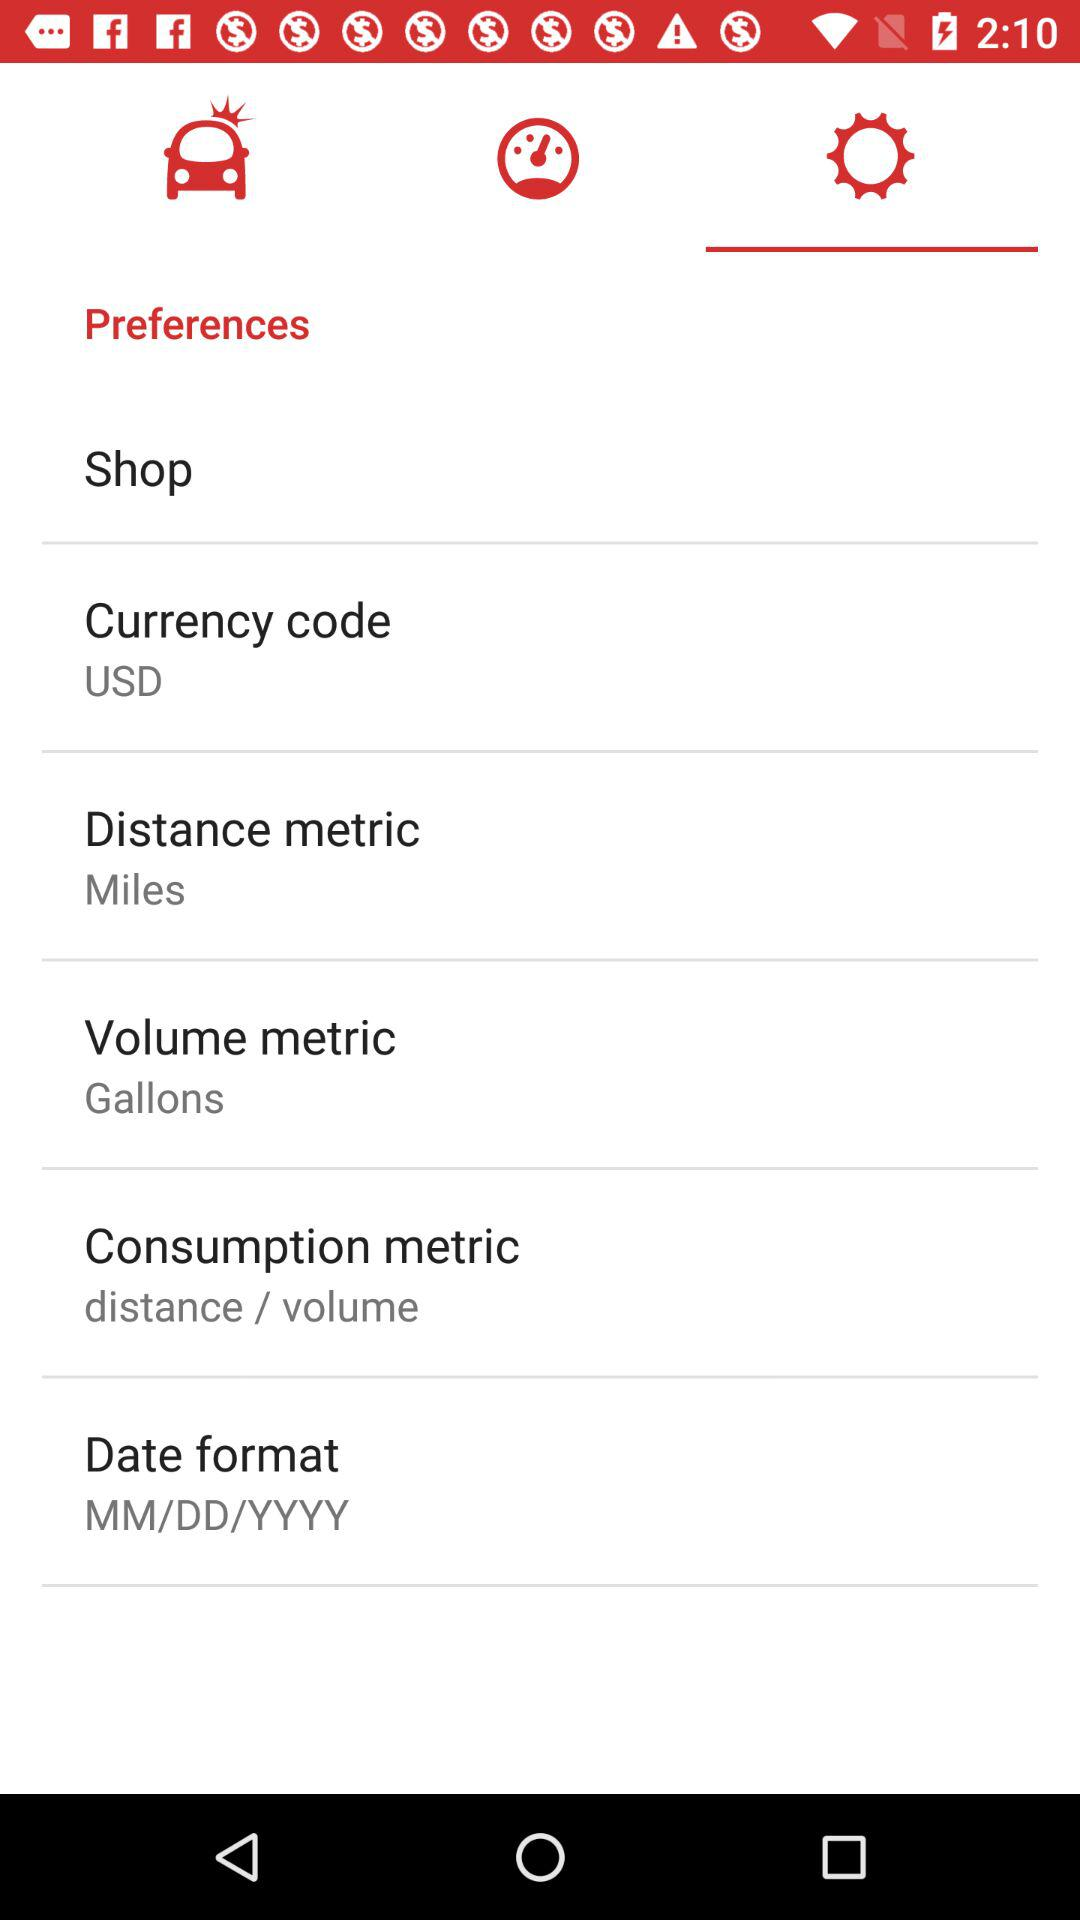What is the selected volume metric? The selected volume metric is gallons. 